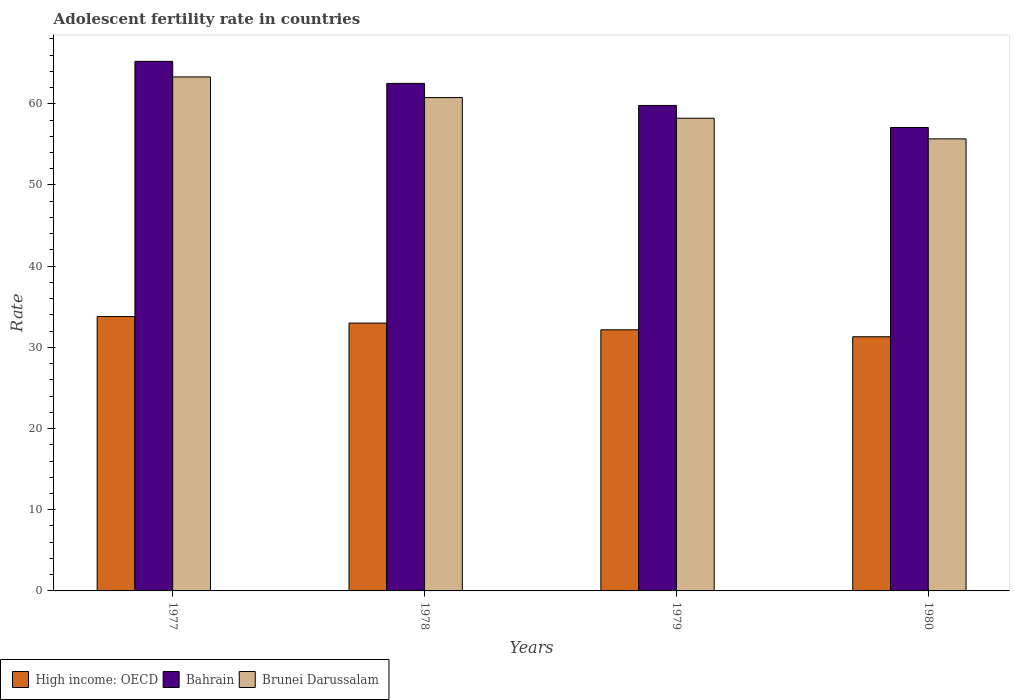Are the number of bars per tick equal to the number of legend labels?
Make the answer very short. Yes. How many bars are there on the 4th tick from the left?
Offer a very short reply. 3. What is the label of the 4th group of bars from the left?
Offer a terse response. 1980. In how many cases, is the number of bars for a given year not equal to the number of legend labels?
Keep it short and to the point. 0. What is the adolescent fertility rate in Bahrain in 1980?
Offer a very short reply. 57.08. Across all years, what is the maximum adolescent fertility rate in High income: OECD?
Your response must be concise. 33.8. Across all years, what is the minimum adolescent fertility rate in Brunei Darussalam?
Your response must be concise. 55.68. What is the total adolescent fertility rate in Brunei Darussalam in the graph?
Your answer should be compact. 237.97. What is the difference between the adolescent fertility rate in Brunei Darussalam in 1977 and that in 1978?
Keep it short and to the point. 2.54. What is the difference between the adolescent fertility rate in Brunei Darussalam in 1978 and the adolescent fertility rate in Bahrain in 1979?
Your response must be concise. 0.97. What is the average adolescent fertility rate in High income: OECD per year?
Provide a short and direct response. 32.56. In the year 1980, what is the difference between the adolescent fertility rate in Bahrain and adolescent fertility rate in Brunei Darussalam?
Your response must be concise. 1.4. In how many years, is the adolescent fertility rate in Bahrain greater than 22?
Your answer should be very brief. 4. What is the ratio of the adolescent fertility rate in Bahrain in 1978 to that in 1980?
Ensure brevity in your answer.  1.1. Is the difference between the adolescent fertility rate in Bahrain in 1978 and 1979 greater than the difference between the adolescent fertility rate in Brunei Darussalam in 1978 and 1979?
Your answer should be very brief. Yes. What is the difference between the highest and the second highest adolescent fertility rate in Bahrain?
Your response must be concise. 2.72. What is the difference between the highest and the lowest adolescent fertility rate in Bahrain?
Your answer should be very brief. 8.15. What does the 1st bar from the left in 1980 represents?
Ensure brevity in your answer.  High income: OECD. What does the 2nd bar from the right in 1980 represents?
Ensure brevity in your answer.  Bahrain. How many bars are there?
Offer a terse response. 12. How many years are there in the graph?
Your response must be concise. 4. Does the graph contain grids?
Your response must be concise. No. How many legend labels are there?
Your answer should be very brief. 3. What is the title of the graph?
Offer a terse response. Adolescent fertility rate in countries. Does "Somalia" appear as one of the legend labels in the graph?
Give a very brief answer. No. What is the label or title of the X-axis?
Ensure brevity in your answer.  Years. What is the label or title of the Y-axis?
Offer a terse response. Rate. What is the Rate in High income: OECD in 1977?
Your answer should be very brief. 33.8. What is the Rate of Bahrain in 1977?
Provide a succinct answer. 65.22. What is the Rate in Brunei Darussalam in 1977?
Keep it short and to the point. 63.31. What is the Rate of High income: OECD in 1978?
Ensure brevity in your answer.  32.99. What is the Rate of Bahrain in 1978?
Give a very brief answer. 62.51. What is the Rate in Brunei Darussalam in 1978?
Offer a very short reply. 60.76. What is the Rate of High income: OECD in 1979?
Provide a short and direct response. 32.16. What is the Rate in Bahrain in 1979?
Offer a very short reply. 59.79. What is the Rate of Brunei Darussalam in 1979?
Ensure brevity in your answer.  58.22. What is the Rate of High income: OECD in 1980?
Your response must be concise. 31.3. What is the Rate in Bahrain in 1980?
Offer a terse response. 57.08. What is the Rate of Brunei Darussalam in 1980?
Keep it short and to the point. 55.68. Across all years, what is the maximum Rate in High income: OECD?
Make the answer very short. 33.8. Across all years, what is the maximum Rate in Bahrain?
Provide a succinct answer. 65.22. Across all years, what is the maximum Rate of Brunei Darussalam?
Give a very brief answer. 63.31. Across all years, what is the minimum Rate of High income: OECD?
Your answer should be compact. 31.3. Across all years, what is the minimum Rate in Bahrain?
Give a very brief answer. 57.08. Across all years, what is the minimum Rate in Brunei Darussalam?
Provide a succinct answer. 55.68. What is the total Rate of High income: OECD in the graph?
Make the answer very short. 130.25. What is the total Rate in Bahrain in the graph?
Give a very brief answer. 244.61. What is the total Rate in Brunei Darussalam in the graph?
Provide a succinct answer. 237.97. What is the difference between the Rate of High income: OECD in 1977 and that in 1978?
Your response must be concise. 0.8. What is the difference between the Rate in Bahrain in 1977 and that in 1978?
Offer a very short reply. 2.72. What is the difference between the Rate of Brunei Darussalam in 1977 and that in 1978?
Provide a succinct answer. 2.54. What is the difference between the Rate of High income: OECD in 1977 and that in 1979?
Offer a very short reply. 1.63. What is the difference between the Rate in Bahrain in 1977 and that in 1979?
Provide a succinct answer. 5.43. What is the difference between the Rate in Brunei Darussalam in 1977 and that in 1979?
Your response must be concise. 5.08. What is the difference between the Rate of High income: OECD in 1977 and that in 1980?
Your answer should be compact. 2.49. What is the difference between the Rate of Bahrain in 1977 and that in 1980?
Your response must be concise. 8.15. What is the difference between the Rate in Brunei Darussalam in 1977 and that in 1980?
Your answer should be compact. 7.63. What is the difference between the Rate in High income: OECD in 1978 and that in 1979?
Your answer should be compact. 0.83. What is the difference between the Rate in Bahrain in 1978 and that in 1979?
Your answer should be compact. 2.72. What is the difference between the Rate in Brunei Darussalam in 1978 and that in 1979?
Provide a short and direct response. 2.54. What is the difference between the Rate in High income: OECD in 1978 and that in 1980?
Offer a terse response. 1.69. What is the difference between the Rate in Bahrain in 1978 and that in 1980?
Your answer should be compact. 5.43. What is the difference between the Rate in Brunei Darussalam in 1978 and that in 1980?
Your answer should be compact. 5.08. What is the difference between the Rate in High income: OECD in 1979 and that in 1980?
Keep it short and to the point. 0.86. What is the difference between the Rate in Bahrain in 1979 and that in 1980?
Make the answer very short. 2.72. What is the difference between the Rate in Brunei Darussalam in 1979 and that in 1980?
Offer a terse response. 2.54. What is the difference between the Rate of High income: OECD in 1977 and the Rate of Bahrain in 1978?
Keep it short and to the point. -28.71. What is the difference between the Rate in High income: OECD in 1977 and the Rate in Brunei Darussalam in 1978?
Provide a short and direct response. -26.97. What is the difference between the Rate of Bahrain in 1977 and the Rate of Brunei Darussalam in 1978?
Offer a very short reply. 4.46. What is the difference between the Rate in High income: OECD in 1977 and the Rate in Bahrain in 1979?
Your answer should be compact. -26. What is the difference between the Rate of High income: OECD in 1977 and the Rate of Brunei Darussalam in 1979?
Provide a succinct answer. -24.43. What is the difference between the Rate of Bahrain in 1977 and the Rate of Brunei Darussalam in 1979?
Your response must be concise. 7. What is the difference between the Rate of High income: OECD in 1977 and the Rate of Bahrain in 1980?
Offer a terse response. -23.28. What is the difference between the Rate of High income: OECD in 1977 and the Rate of Brunei Darussalam in 1980?
Give a very brief answer. -21.88. What is the difference between the Rate of Bahrain in 1977 and the Rate of Brunei Darussalam in 1980?
Your answer should be very brief. 9.55. What is the difference between the Rate in High income: OECD in 1978 and the Rate in Bahrain in 1979?
Provide a succinct answer. -26.8. What is the difference between the Rate in High income: OECD in 1978 and the Rate in Brunei Darussalam in 1979?
Your answer should be very brief. -25.23. What is the difference between the Rate in Bahrain in 1978 and the Rate in Brunei Darussalam in 1979?
Your response must be concise. 4.29. What is the difference between the Rate in High income: OECD in 1978 and the Rate in Bahrain in 1980?
Offer a terse response. -24.09. What is the difference between the Rate of High income: OECD in 1978 and the Rate of Brunei Darussalam in 1980?
Make the answer very short. -22.69. What is the difference between the Rate in Bahrain in 1978 and the Rate in Brunei Darussalam in 1980?
Keep it short and to the point. 6.83. What is the difference between the Rate of High income: OECD in 1979 and the Rate of Bahrain in 1980?
Your response must be concise. -24.92. What is the difference between the Rate in High income: OECD in 1979 and the Rate in Brunei Darussalam in 1980?
Give a very brief answer. -23.52. What is the difference between the Rate in Bahrain in 1979 and the Rate in Brunei Darussalam in 1980?
Ensure brevity in your answer.  4.12. What is the average Rate in High income: OECD per year?
Your response must be concise. 32.56. What is the average Rate of Bahrain per year?
Your response must be concise. 61.15. What is the average Rate of Brunei Darussalam per year?
Provide a short and direct response. 59.49. In the year 1977, what is the difference between the Rate of High income: OECD and Rate of Bahrain?
Your response must be concise. -31.43. In the year 1977, what is the difference between the Rate in High income: OECD and Rate in Brunei Darussalam?
Make the answer very short. -29.51. In the year 1977, what is the difference between the Rate in Bahrain and Rate in Brunei Darussalam?
Make the answer very short. 1.92. In the year 1978, what is the difference between the Rate in High income: OECD and Rate in Bahrain?
Your response must be concise. -29.52. In the year 1978, what is the difference between the Rate in High income: OECD and Rate in Brunei Darussalam?
Offer a very short reply. -27.77. In the year 1978, what is the difference between the Rate of Bahrain and Rate of Brunei Darussalam?
Your response must be concise. 1.75. In the year 1979, what is the difference between the Rate in High income: OECD and Rate in Bahrain?
Your response must be concise. -27.63. In the year 1979, what is the difference between the Rate of High income: OECD and Rate of Brunei Darussalam?
Your answer should be compact. -26.06. In the year 1979, what is the difference between the Rate of Bahrain and Rate of Brunei Darussalam?
Your answer should be very brief. 1.57. In the year 1980, what is the difference between the Rate in High income: OECD and Rate in Bahrain?
Offer a terse response. -25.77. In the year 1980, what is the difference between the Rate of High income: OECD and Rate of Brunei Darussalam?
Your response must be concise. -24.37. In the year 1980, what is the difference between the Rate of Bahrain and Rate of Brunei Darussalam?
Ensure brevity in your answer.  1.4. What is the ratio of the Rate in High income: OECD in 1977 to that in 1978?
Your answer should be very brief. 1.02. What is the ratio of the Rate of Bahrain in 1977 to that in 1978?
Make the answer very short. 1.04. What is the ratio of the Rate of Brunei Darussalam in 1977 to that in 1978?
Offer a very short reply. 1.04. What is the ratio of the Rate of High income: OECD in 1977 to that in 1979?
Your response must be concise. 1.05. What is the ratio of the Rate of Bahrain in 1977 to that in 1979?
Offer a terse response. 1.09. What is the ratio of the Rate of Brunei Darussalam in 1977 to that in 1979?
Provide a succinct answer. 1.09. What is the ratio of the Rate of High income: OECD in 1977 to that in 1980?
Your response must be concise. 1.08. What is the ratio of the Rate of Bahrain in 1977 to that in 1980?
Your answer should be compact. 1.14. What is the ratio of the Rate in Brunei Darussalam in 1977 to that in 1980?
Your answer should be compact. 1.14. What is the ratio of the Rate of High income: OECD in 1978 to that in 1979?
Ensure brevity in your answer.  1.03. What is the ratio of the Rate in Bahrain in 1978 to that in 1979?
Keep it short and to the point. 1.05. What is the ratio of the Rate of Brunei Darussalam in 1978 to that in 1979?
Provide a short and direct response. 1.04. What is the ratio of the Rate of High income: OECD in 1978 to that in 1980?
Give a very brief answer. 1.05. What is the ratio of the Rate in Bahrain in 1978 to that in 1980?
Make the answer very short. 1.1. What is the ratio of the Rate in Brunei Darussalam in 1978 to that in 1980?
Your answer should be very brief. 1.09. What is the ratio of the Rate of High income: OECD in 1979 to that in 1980?
Your response must be concise. 1.03. What is the ratio of the Rate in Bahrain in 1979 to that in 1980?
Give a very brief answer. 1.05. What is the ratio of the Rate of Brunei Darussalam in 1979 to that in 1980?
Your answer should be very brief. 1.05. What is the difference between the highest and the second highest Rate in High income: OECD?
Your response must be concise. 0.8. What is the difference between the highest and the second highest Rate in Bahrain?
Your response must be concise. 2.72. What is the difference between the highest and the second highest Rate of Brunei Darussalam?
Your answer should be compact. 2.54. What is the difference between the highest and the lowest Rate of High income: OECD?
Keep it short and to the point. 2.49. What is the difference between the highest and the lowest Rate in Bahrain?
Offer a terse response. 8.15. What is the difference between the highest and the lowest Rate in Brunei Darussalam?
Offer a very short reply. 7.63. 